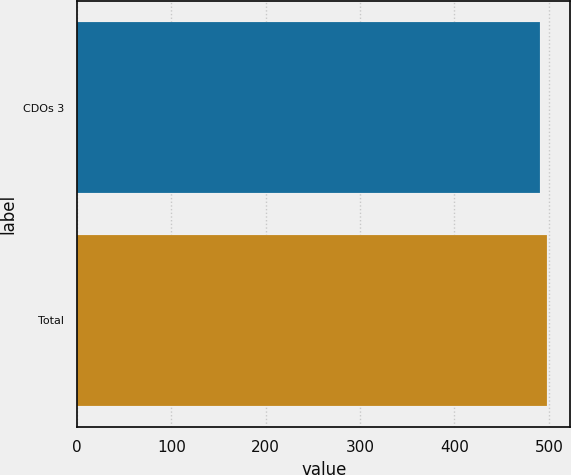<chart> <loc_0><loc_0><loc_500><loc_500><bar_chart><fcel>CDOs 3<fcel>Total<nl><fcel>491<fcel>498<nl></chart> 